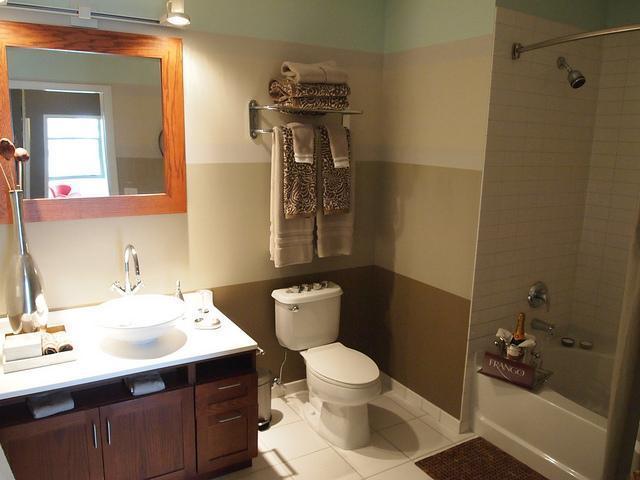How many toilets are in this room?
Give a very brief answer. 1. How many mirrors are in this scene?
Give a very brief answer. 1. How many sinks can be seen?
Give a very brief answer. 2. How many horses are there?
Give a very brief answer. 0. 